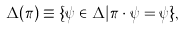<formula> <loc_0><loc_0><loc_500><loc_500>\Delta ( \pi ) \equiv \{ \psi \in \Delta | \pi \cdot \psi = \psi \} ,</formula> 